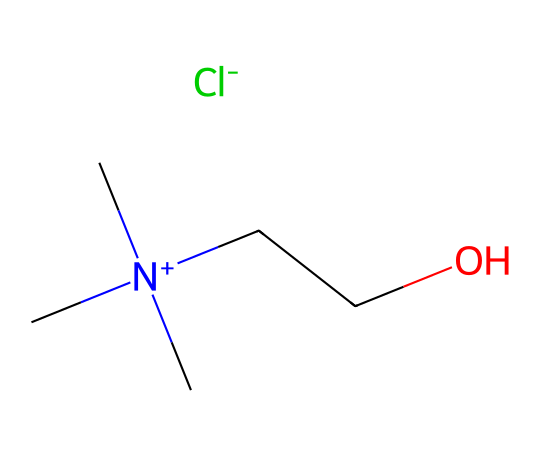What is the chemical name of this structure? The SMILES representation indicates that the chemical includes a choline cation (C[N+](C)(C)CCO) paired with a chloride anion ([Cl-]). Hence, the overall chemical name is choline chloride.
Answer: choline chloride How many carbon atoms are present in this ionic liquid? By analyzing the SMILES, there are four carbon atoms indicated in the choline part (C[N+](C)(C)CC) without counting the carbon of the hydroxyl group. So, the total is four.
Answer: four What is the charge of the cation in this compound? In the given structure, the cation consists of a nitrogen atom with a positive charge ([N+]), indicating that the cation has a single positive charge.
Answer: positive What type of ions are present in this ionic liquid? This ionic liquid consists of a cation (choline) and an anion (chloride), thus, it contains a cationic and anionic species.
Answer: cationic and anionic How many hydrogen atoms are bonded to the nitrogen in this ionic liquid? The nitrogen in the structure is bonded to three methyl groups (as indicated by the three C's branching from N). Thus, it does not have any hydrogen atoms directly bonded to nitrogen.
Answer: zero What property makes choline chloride suitable for cleaning solar panels? Choline chloride is known for its low volatility and non-toxic characteristics, making it environmentally friendly, which is essential for cleaning applications in solar panel maintenance.
Answer: environmentally friendly Which functional group is present in choline chloride? The structure contains an alcohol group (-OH) from the hydroxyl connected to carbon, constituting a functional group present in choline chloride.
Answer: alcohol group 